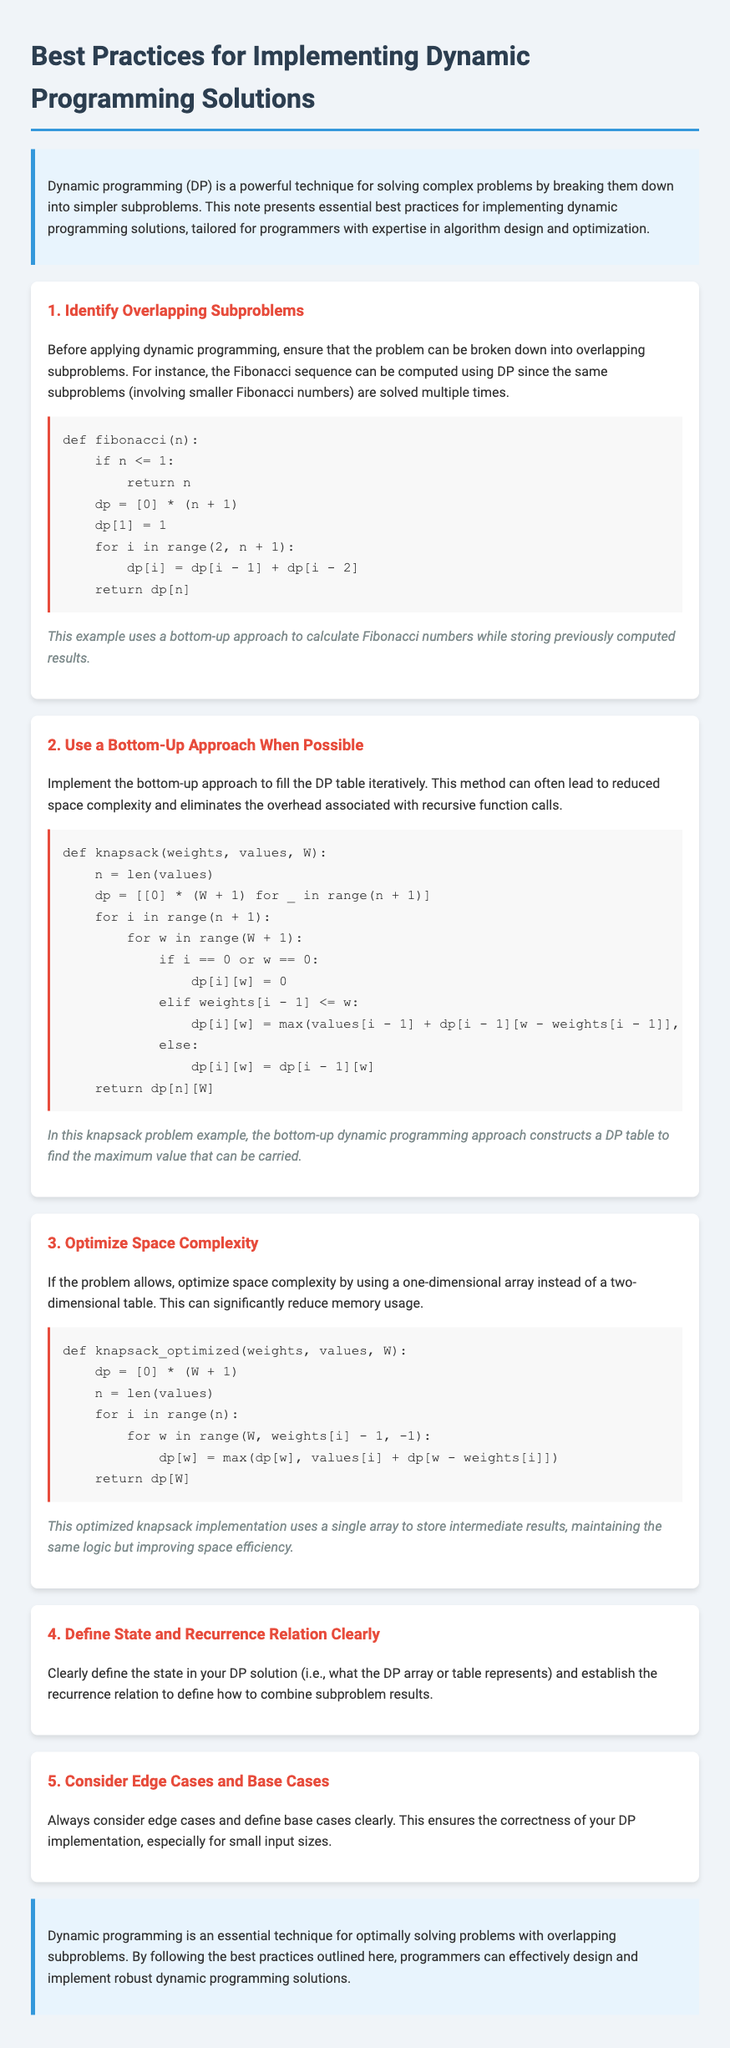What is the title of the document? The title is mentioned in the `<title>` tag of the HTML document.
Answer: Best Practices for Implementing Dynamic Programming Solutions How many best practices are outlined in the document? The number of best practices can be counted from the sections in the document.
Answer: Five What problem does the first practice focus on? The first practice discusses identifying the presence of overlapping subproblems in a given problem.
Answer: Overlapping subproblems Which approach is recommended for optimizing space complexity? The document suggests using a one-dimensional array instead of a two-dimensional table to optimize space.
Answer: One-dimensional array What is the primary function discussed in the second practice? The second practice describes a dynamic programming solution for the knapsack problem.
Answer: Knapsack What common programming technique is mainly discussed in the document? The document is focused on techniques related to solving problems in an efficient manner.
Answer: Dynamic programming In which section would you find the recurrence relation discussed? This topic is mentioned in the section that addresses defining state and recurrence clearly.
Answer: Define State and Recurrence Relation Clearly What are the two main considerations mentioned for ensuring correctness in a DP implementation? The document emphasizes considering edge cases and defining base cases.
Answer: Edge cases and Base cases 